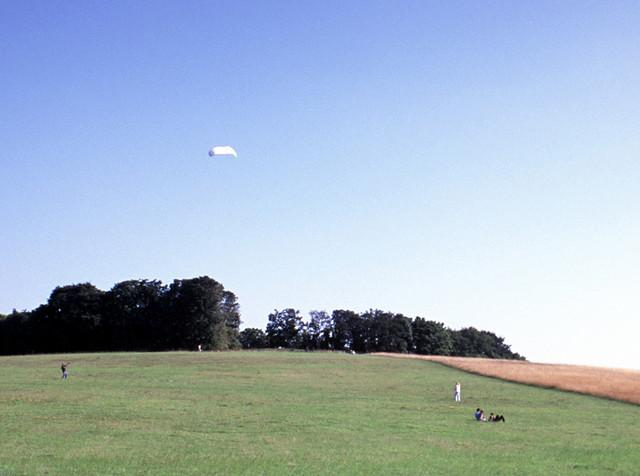What type of location is being visited? Please explain your reasoning. field. It is a large open grassy area. 